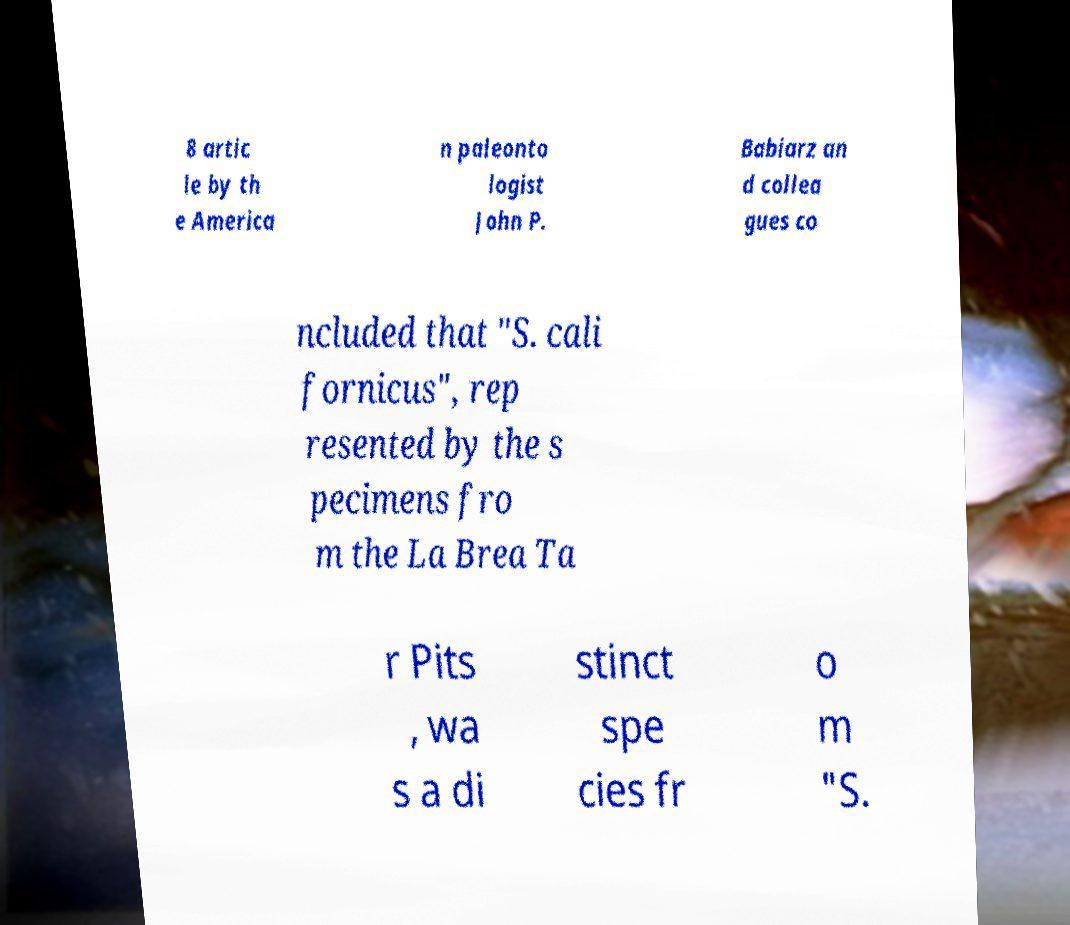I need the written content from this picture converted into text. Can you do that? 8 artic le by th e America n paleonto logist John P. Babiarz an d collea gues co ncluded that "S. cali fornicus", rep resented by the s pecimens fro m the La Brea Ta r Pits , wa s a di stinct spe cies fr o m "S. 